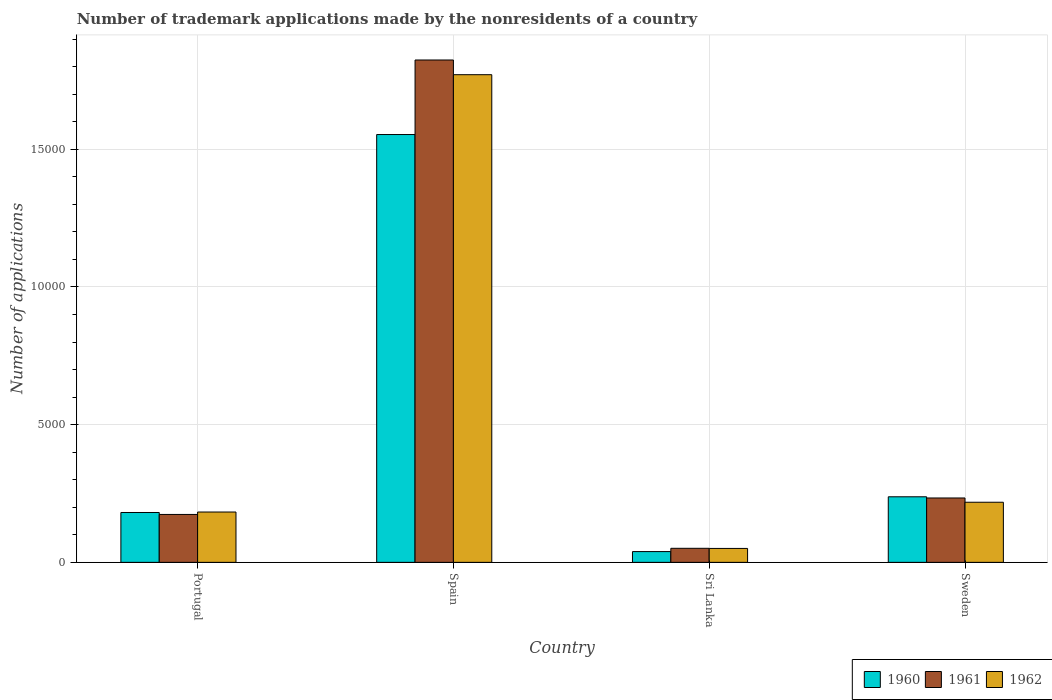How many groups of bars are there?
Give a very brief answer. 4. What is the label of the 3rd group of bars from the left?
Ensure brevity in your answer.  Sri Lanka. In how many cases, is the number of bars for a given country not equal to the number of legend labels?
Your answer should be very brief. 0. What is the number of trademark applications made by the nonresidents in 1962 in Portugal?
Give a very brief answer. 1828. Across all countries, what is the maximum number of trademark applications made by the nonresidents in 1962?
Provide a succinct answer. 1.77e+04. Across all countries, what is the minimum number of trademark applications made by the nonresidents in 1961?
Offer a very short reply. 510. In which country was the number of trademark applications made by the nonresidents in 1962 maximum?
Make the answer very short. Spain. In which country was the number of trademark applications made by the nonresidents in 1960 minimum?
Offer a terse response. Sri Lanka. What is the total number of trademark applications made by the nonresidents in 1960 in the graph?
Keep it short and to the point. 2.01e+04. What is the difference between the number of trademark applications made by the nonresidents in 1961 in Portugal and that in Sri Lanka?
Offer a very short reply. 1230. What is the difference between the number of trademark applications made by the nonresidents in 1960 in Portugal and the number of trademark applications made by the nonresidents in 1961 in Sri Lanka?
Your answer should be compact. 1301. What is the average number of trademark applications made by the nonresidents in 1962 per country?
Your response must be concise. 5556.75. What is the difference between the number of trademark applications made by the nonresidents of/in 1960 and number of trademark applications made by the nonresidents of/in 1962 in Sweden?
Provide a short and direct response. 198. In how many countries, is the number of trademark applications made by the nonresidents in 1961 greater than 4000?
Your response must be concise. 1. What is the ratio of the number of trademark applications made by the nonresidents in 1960 in Portugal to that in Sweden?
Keep it short and to the point. 0.76. Is the number of trademark applications made by the nonresidents in 1960 in Spain less than that in Sweden?
Give a very brief answer. No. Is the difference between the number of trademark applications made by the nonresidents in 1960 in Portugal and Sri Lanka greater than the difference between the number of trademark applications made by the nonresidents in 1962 in Portugal and Sri Lanka?
Your response must be concise. Yes. What is the difference between the highest and the second highest number of trademark applications made by the nonresidents in 1962?
Your answer should be very brief. -1.59e+04. What is the difference between the highest and the lowest number of trademark applications made by the nonresidents in 1962?
Offer a very short reply. 1.72e+04. In how many countries, is the number of trademark applications made by the nonresidents in 1960 greater than the average number of trademark applications made by the nonresidents in 1960 taken over all countries?
Your answer should be compact. 1. Is the sum of the number of trademark applications made by the nonresidents in 1962 in Portugal and Spain greater than the maximum number of trademark applications made by the nonresidents in 1960 across all countries?
Offer a very short reply. Yes. What does the 2nd bar from the right in Portugal represents?
Your answer should be very brief. 1961. Is it the case that in every country, the sum of the number of trademark applications made by the nonresidents in 1962 and number of trademark applications made by the nonresidents in 1960 is greater than the number of trademark applications made by the nonresidents in 1961?
Keep it short and to the point. Yes. How many bars are there?
Your response must be concise. 12. Are all the bars in the graph horizontal?
Keep it short and to the point. No. How many countries are there in the graph?
Offer a very short reply. 4. Are the values on the major ticks of Y-axis written in scientific E-notation?
Keep it short and to the point. No. Where does the legend appear in the graph?
Offer a very short reply. Bottom right. What is the title of the graph?
Your response must be concise. Number of trademark applications made by the nonresidents of a country. Does "1988" appear as one of the legend labels in the graph?
Provide a short and direct response. No. What is the label or title of the X-axis?
Offer a very short reply. Country. What is the label or title of the Y-axis?
Make the answer very short. Number of applications. What is the Number of applications of 1960 in Portugal?
Offer a very short reply. 1811. What is the Number of applications in 1961 in Portugal?
Offer a terse response. 1740. What is the Number of applications in 1962 in Portugal?
Give a very brief answer. 1828. What is the Number of applications of 1960 in Spain?
Your answer should be very brief. 1.55e+04. What is the Number of applications of 1961 in Spain?
Offer a very short reply. 1.82e+04. What is the Number of applications of 1962 in Spain?
Your response must be concise. 1.77e+04. What is the Number of applications of 1960 in Sri Lanka?
Your response must be concise. 391. What is the Number of applications in 1961 in Sri Lanka?
Provide a succinct answer. 510. What is the Number of applications in 1962 in Sri Lanka?
Your answer should be compact. 506. What is the Number of applications of 1960 in Sweden?
Offer a very short reply. 2381. What is the Number of applications in 1961 in Sweden?
Offer a terse response. 2338. What is the Number of applications in 1962 in Sweden?
Make the answer very short. 2183. Across all countries, what is the maximum Number of applications of 1960?
Give a very brief answer. 1.55e+04. Across all countries, what is the maximum Number of applications in 1961?
Keep it short and to the point. 1.82e+04. Across all countries, what is the maximum Number of applications of 1962?
Provide a succinct answer. 1.77e+04. Across all countries, what is the minimum Number of applications in 1960?
Give a very brief answer. 391. Across all countries, what is the minimum Number of applications in 1961?
Your answer should be compact. 510. Across all countries, what is the minimum Number of applications of 1962?
Provide a succinct answer. 506. What is the total Number of applications of 1960 in the graph?
Your answer should be compact. 2.01e+04. What is the total Number of applications in 1961 in the graph?
Provide a short and direct response. 2.28e+04. What is the total Number of applications of 1962 in the graph?
Make the answer very short. 2.22e+04. What is the difference between the Number of applications of 1960 in Portugal and that in Spain?
Keep it short and to the point. -1.37e+04. What is the difference between the Number of applications of 1961 in Portugal and that in Spain?
Offer a very short reply. -1.65e+04. What is the difference between the Number of applications of 1962 in Portugal and that in Spain?
Your response must be concise. -1.59e+04. What is the difference between the Number of applications of 1960 in Portugal and that in Sri Lanka?
Provide a short and direct response. 1420. What is the difference between the Number of applications of 1961 in Portugal and that in Sri Lanka?
Your answer should be compact. 1230. What is the difference between the Number of applications in 1962 in Portugal and that in Sri Lanka?
Ensure brevity in your answer.  1322. What is the difference between the Number of applications in 1960 in Portugal and that in Sweden?
Offer a very short reply. -570. What is the difference between the Number of applications of 1961 in Portugal and that in Sweden?
Provide a succinct answer. -598. What is the difference between the Number of applications in 1962 in Portugal and that in Sweden?
Offer a terse response. -355. What is the difference between the Number of applications in 1960 in Spain and that in Sri Lanka?
Your answer should be compact. 1.51e+04. What is the difference between the Number of applications in 1961 in Spain and that in Sri Lanka?
Provide a short and direct response. 1.77e+04. What is the difference between the Number of applications of 1962 in Spain and that in Sri Lanka?
Your answer should be very brief. 1.72e+04. What is the difference between the Number of applications in 1960 in Spain and that in Sweden?
Offer a terse response. 1.32e+04. What is the difference between the Number of applications in 1961 in Spain and that in Sweden?
Provide a short and direct response. 1.59e+04. What is the difference between the Number of applications in 1962 in Spain and that in Sweden?
Your answer should be compact. 1.55e+04. What is the difference between the Number of applications in 1960 in Sri Lanka and that in Sweden?
Keep it short and to the point. -1990. What is the difference between the Number of applications of 1961 in Sri Lanka and that in Sweden?
Offer a very short reply. -1828. What is the difference between the Number of applications of 1962 in Sri Lanka and that in Sweden?
Ensure brevity in your answer.  -1677. What is the difference between the Number of applications in 1960 in Portugal and the Number of applications in 1961 in Spain?
Your answer should be very brief. -1.64e+04. What is the difference between the Number of applications of 1960 in Portugal and the Number of applications of 1962 in Spain?
Your answer should be very brief. -1.59e+04. What is the difference between the Number of applications of 1961 in Portugal and the Number of applications of 1962 in Spain?
Give a very brief answer. -1.60e+04. What is the difference between the Number of applications of 1960 in Portugal and the Number of applications of 1961 in Sri Lanka?
Your answer should be very brief. 1301. What is the difference between the Number of applications of 1960 in Portugal and the Number of applications of 1962 in Sri Lanka?
Make the answer very short. 1305. What is the difference between the Number of applications in 1961 in Portugal and the Number of applications in 1962 in Sri Lanka?
Offer a terse response. 1234. What is the difference between the Number of applications of 1960 in Portugal and the Number of applications of 1961 in Sweden?
Your answer should be very brief. -527. What is the difference between the Number of applications of 1960 in Portugal and the Number of applications of 1962 in Sweden?
Your response must be concise. -372. What is the difference between the Number of applications in 1961 in Portugal and the Number of applications in 1962 in Sweden?
Provide a succinct answer. -443. What is the difference between the Number of applications in 1960 in Spain and the Number of applications in 1961 in Sri Lanka?
Keep it short and to the point. 1.50e+04. What is the difference between the Number of applications in 1960 in Spain and the Number of applications in 1962 in Sri Lanka?
Offer a terse response. 1.50e+04. What is the difference between the Number of applications of 1961 in Spain and the Number of applications of 1962 in Sri Lanka?
Keep it short and to the point. 1.77e+04. What is the difference between the Number of applications in 1960 in Spain and the Number of applications in 1961 in Sweden?
Your response must be concise. 1.32e+04. What is the difference between the Number of applications in 1960 in Spain and the Number of applications in 1962 in Sweden?
Your answer should be very brief. 1.34e+04. What is the difference between the Number of applications in 1961 in Spain and the Number of applications in 1962 in Sweden?
Your answer should be very brief. 1.61e+04. What is the difference between the Number of applications of 1960 in Sri Lanka and the Number of applications of 1961 in Sweden?
Your answer should be compact. -1947. What is the difference between the Number of applications in 1960 in Sri Lanka and the Number of applications in 1962 in Sweden?
Your answer should be compact. -1792. What is the difference between the Number of applications in 1961 in Sri Lanka and the Number of applications in 1962 in Sweden?
Make the answer very short. -1673. What is the average Number of applications of 1960 per country?
Your answer should be very brief. 5030. What is the average Number of applications in 1961 per country?
Keep it short and to the point. 5708. What is the average Number of applications of 1962 per country?
Offer a terse response. 5556.75. What is the difference between the Number of applications of 1960 and Number of applications of 1961 in Portugal?
Give a very brief answer. 71. What is the difference between the Number of applications in 1960 and Number of applications in 1962 in Portugal?
Keep it short and to the point. -17. What is the difference between the Number of applications in 1961 and Number of applications in 1962 in Portugal?
Make the answer very short. -88. What is the difference between the Number of applications in 1960 and Number of applications in 1961 in Spain?
Offer a very short reply. -2707. What is the difference between the Number of applications of 1960 and Number of applications of 1962 in Spain?
Keep it short and to the point. -2173. What is the difference between the Number of applications of 1961 and Number of applications of 1962 in Spain?
Make the answer very short. 534. What is the difference between the Number of applications in 1960 and Number of applications in 1961 in Sri Lanka?
Offer a very short reply. -119. What is the difference between the Number of applications of 1960 and Number of applications of 1962 in Sri Lanka?
Provide a succinct answer. -115. What is the difference between the Number of applications in 1961 and Number of applications in 1962 in Sri Lanka?
Offer a terse response. 4. What is the difference between the Number of applications in 1960 and Number of applications in 1961 in Sweden?
Ensure brevity in your answer.  43. What is the difference between the Number of applications of 1960 and Number of applications of 1962 in Sweden?
Your response must be concise. 198. What is the difference between the Number of applications in 1961 and Number of applications in 1962 in Sweden?
Your response must be concise. 155. What is the ratio of the Number of applications in 1960 in Portugal to that in Spain?
Ensure brevity in your answer.  0.12. What is the ratio of the Number of applications of 1961 in Portugal to that in Spain?
Offer a very short reply. 0.1. What is the ratio of the Number of applications of 1962 in Portugal to that in Spain?
Offer a terse response. 0.1. What is the ratio of the Number of applications of 1960 in Portugal to that in Sri Lanka?
Your response must be concise. 4.63. What is the ratio of the Number of applications of 1961 in Portugal to that in Sri Lanka?
Your answer should be very brief. 3.41. What is the ratio of the Number of applications of 1962 in Portugal to that in Sri Lanka?
Your answer should be very brief. 3.61. What is the ratio of the Number of applications in 1960 in Portugal to that in Sweden?
Keep it short and to the point. 0.76. What is the ratio of the Number of applications of 1961 in Portugal to that in Sweden?
Offer a very short reply. 0.74. What is the ratio of the Number of applications in 1962 in Portugal to that in Sweden?
Make the answer very short. 0.84. What is the ratio of the Number of applications in 1960 in Spain to that in Sri Lanka?
Offer a terse response. 39.74. What is the ratio of the Number of applications in 1961 in Spain to that in Sri Lanka?
Keep it short and to the point. 35.77. What is the ratio of the Number of applications in 1962 in Spain to that in Sri Lanka?
Keep it short and to the point. 35. What is the ratio of the Number of applications in 1960 in Spain to that in Sweden?
Offer a terse response. 6.53. What is the ratio of the Number of applications in 1961 in Spain to that in Sweden?
Keep it short and to the point. 7.8. What is the ratio of the Number of applications in 1962 in Spain to that in Sweden?
Provide a short and direct response. 8.11. What is the ratio of the Number of applications in 1960 in Sri Lanka to that in Sweden?
Provide a short and direct response. 0.16. What is the ratio of the Number of applications of 1961 in Sri Lanka to that in Sweden?
Give a very brief answer. 0.22. What is the ratio of the Number of applications of 1962 in Sri Lanka to that in Sweden?
Your response must be concise. 0.23. What is the difference between the highest and the second highest Number of applications in 1960?
Make the answer very short. 1.32e+04. What is the difference between the highest and the second highest Number of applications of 1961?
Offer a terse response. 1.59e+04. What is the difference between the highest and the second highest Number of applications in 1962?
Your answer should be compact. 1.55e+04. What is the difference between the highest and the lowest Number of applications in 1960?
Your response must be concise. 1.51e+04. What is the difference between the highest and the lowest Number of applications of 1961?
Give a very brief answer. 1.77e+04. What is the difference between the highest and the lowest Number of applications in 1962?
Make the answer very short. 1.72e+04. 